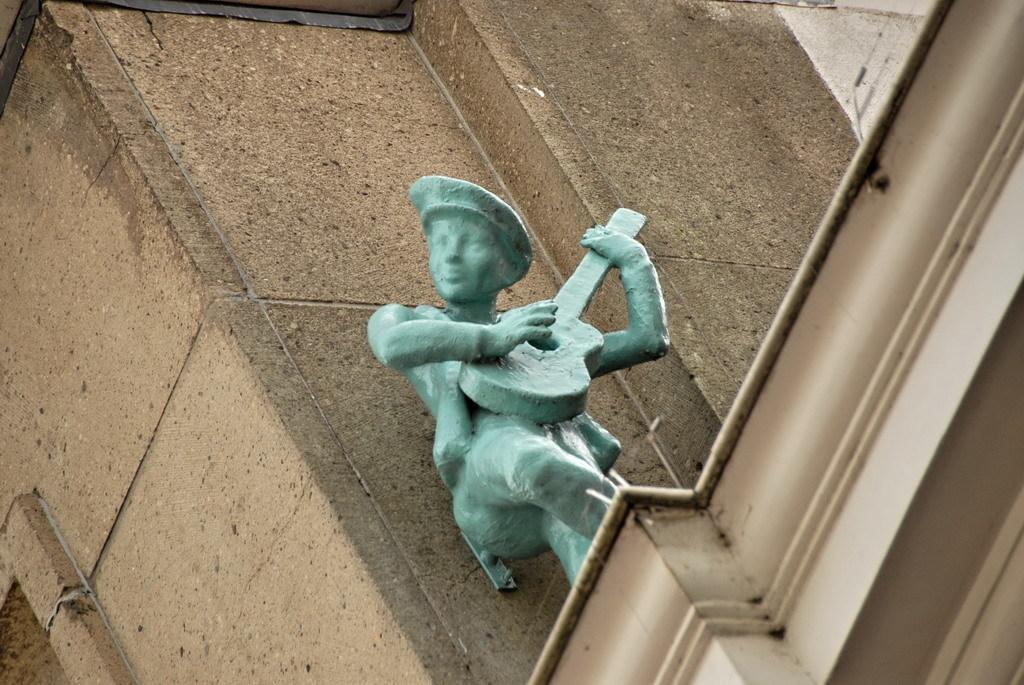What is the color of the wall in the image? The wall in the image is brown. What is the color of the statue in the image? The statue in the image is blue. How is the statue positioned in relation to the wall? The statue is attached to the wall. What type of care is the statue receiving on its birthday in the image? There is no indication of a birthday or care being provided to the statue in the image. 